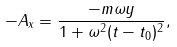<formula> <loc_0><loc_0><loc_500><loc_500>- A _ { x } = \frac { - m \omega y } { 1 + \omega ^ { 2 } ( t - t _ { 0 } ) ^ { 2 } } ,</formula> 